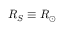Convert formula to latex. <formula><loc_0><loc_0><loc_500><loc_500>R _ { S } \equiv R _ { \odot }</formula> 